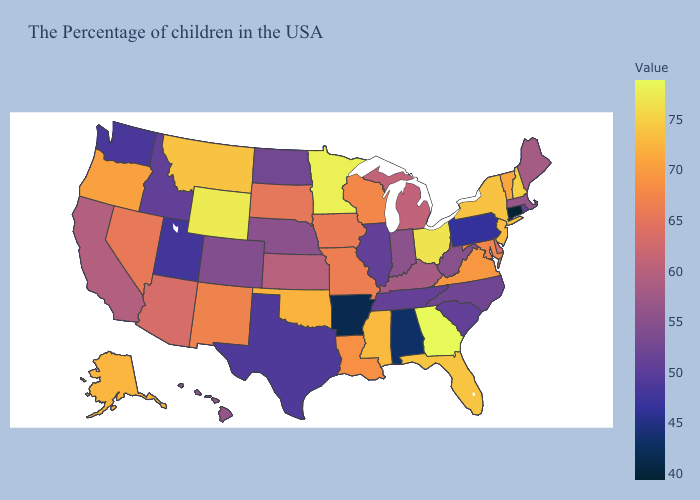Does Connecticut have the lowest value in the USA?
Short answer required. Yes. Which states hav the highest value in the Northeast?
Short answer required. New Hampshire. Does the map have missing data?
Write a very short answer. No. Among the states that border Utah , which have the lowest value?
Short answer required. Idaho. 